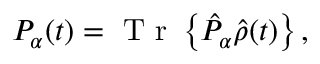Convert formula to latex. <formula><loc_0><loc_0><loc_500><loc_500>P _ { \alpha } ( t ) = T r \left \{ \hat { P } _ { \alpha } \hat { \rho } ( t ) \right \} ,</formula> 